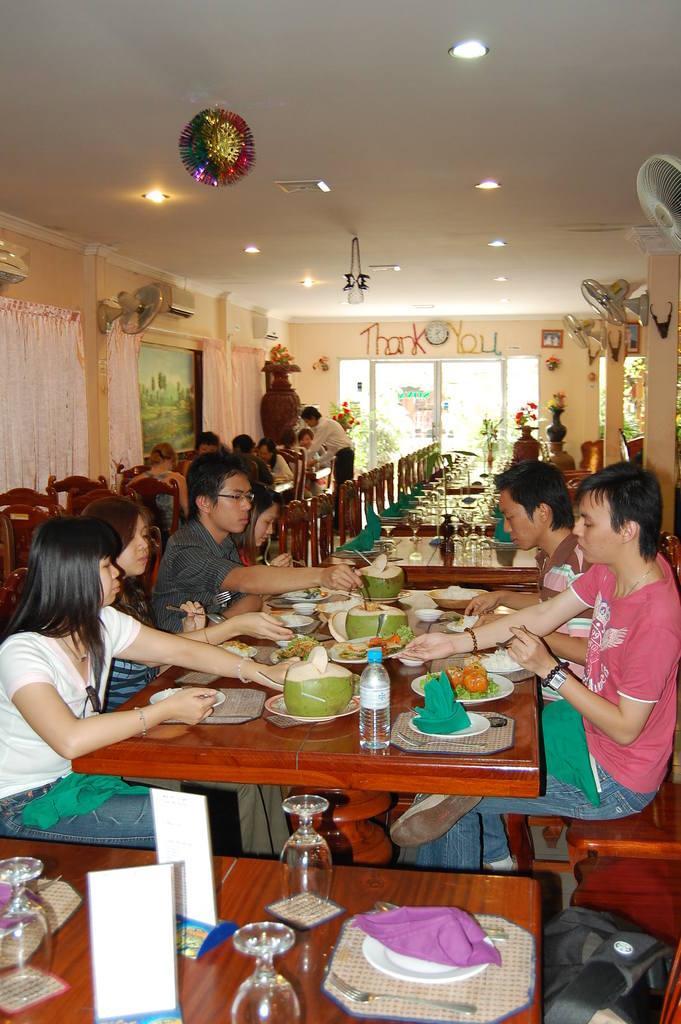Can you describe this image briefly? In this image I see lot of people who are sitting and I also see that there are lot of things on the table. In the background I see lot of chairs, few people over here and tables, I also see that there is a wall, few fans, lights, decorations and the curtains. 